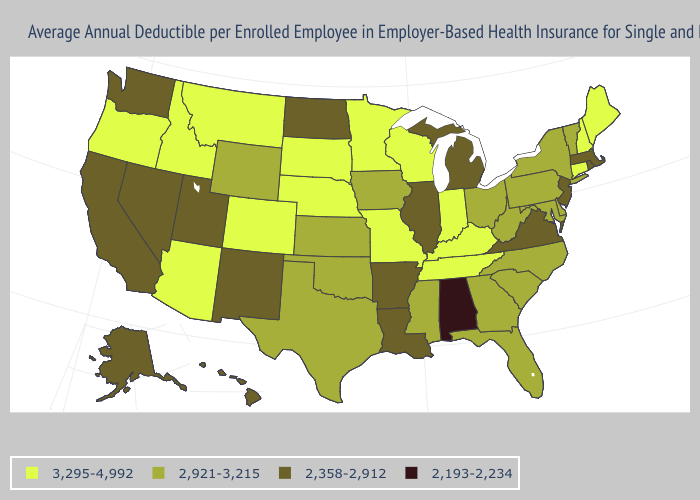What is the value of Rhode Island?
Short answer required. 2,358-2,912. Does North Carolina have a higher value than Wyoming?
Be succinct. No. What is the highest value in the USA?
Keep it brief. 3,295-4,992. Among the states that border Texas , does Arkansas have the lowest value?
Short answer required. Yes. Name the states that have a value in the range 3,295-4,992?
Write a very short answer. Arizona, Colorado, Connecticut, Idaho, Indiana, Kentucky, Maine, Minnesota, Missouri, Montana, Nebraska, New Hampshire, Oregon, South Dakota, Tennessee, Wisconsin. What is the value of Wisconsin?
Keep it brief. 3,295-4,992. Does Kansas have a lower value than Ohio?
Quick response, please. No. What is the value of Delaware?
Short answer required. 2,921-3,215. What is the highest value in the USA?
Quick response, please. 3,295-4,992. Does Maryland have the highest value in the USA?
Be succinct. No. What is the lowest value in states that border New Jersey?
Keep it brief. 2,921-3,215. Name the states that have a value in the range 3,295-4,992?
Short answer required. Arizona, Colorado, Connecticut, Idaho, Indiana, Kentucky, Maine, Minnesota, Missouri, Montana, Nebraska, New Hampshire, Oregon, South Dakota, Tennessee, Wisconsin. Does the map have missing data?
Short answer required. No. What is the lowest value in the USA?
Keep it brief. 2,193-2,234. Name the states that have a value in the range 2,193-2,234?
Quick response, please. Alabama. 